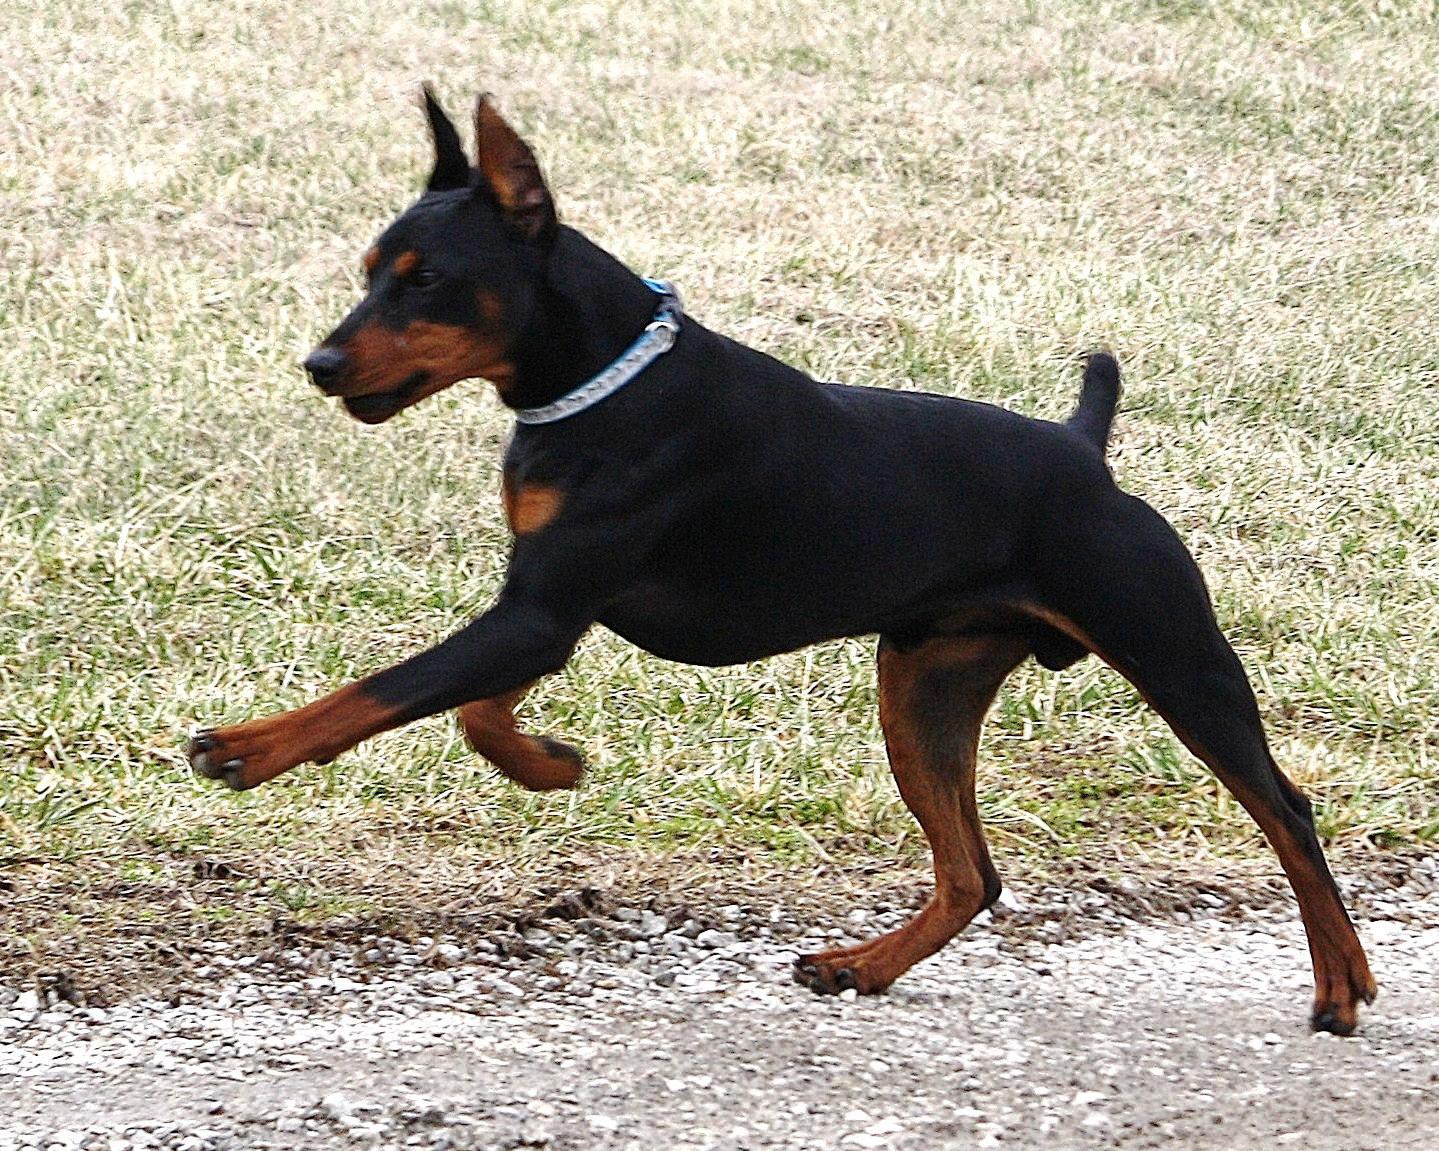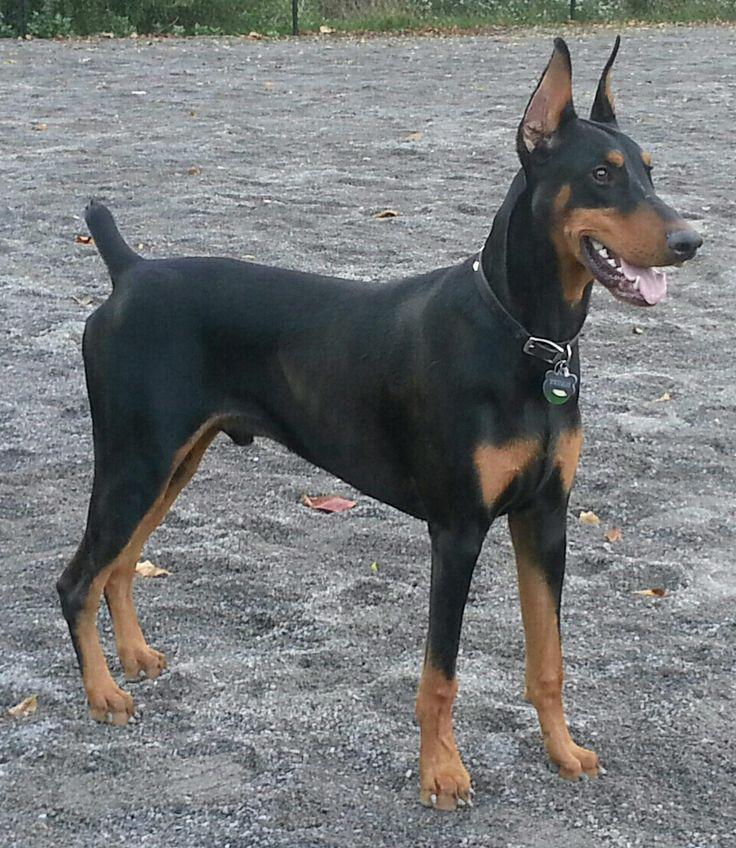The first image is the image on the left, the second image is the image on the right. For the images displayed, is the sentence "Each image features a doberman with erect, upright ears, one of the dobermans depicted has an open mouth, and no doberman has a long tail." factually correct? Answer yes or no. Yes. The first image is the image on the left, the second image is the image on the right. Analyze the images presented: Is the assertion "The two dogs' bodies are pointed in opposite directions." valid? Answer yes or no. Yes. 